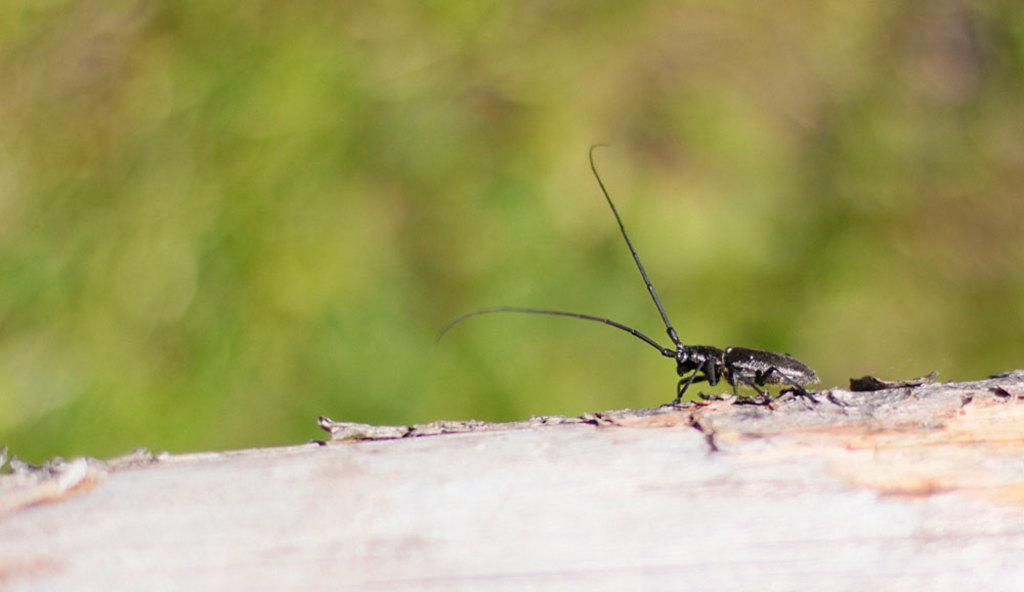What type of creature can be seen in the image? There is an insect in the image. What color is the insect? The insect is black in color. What can be seen in the background of the image? The background of the image is greenery. What type of part can be seen whistling in the image? There is no part or whistling present in the image; it features an insect and greenery. 